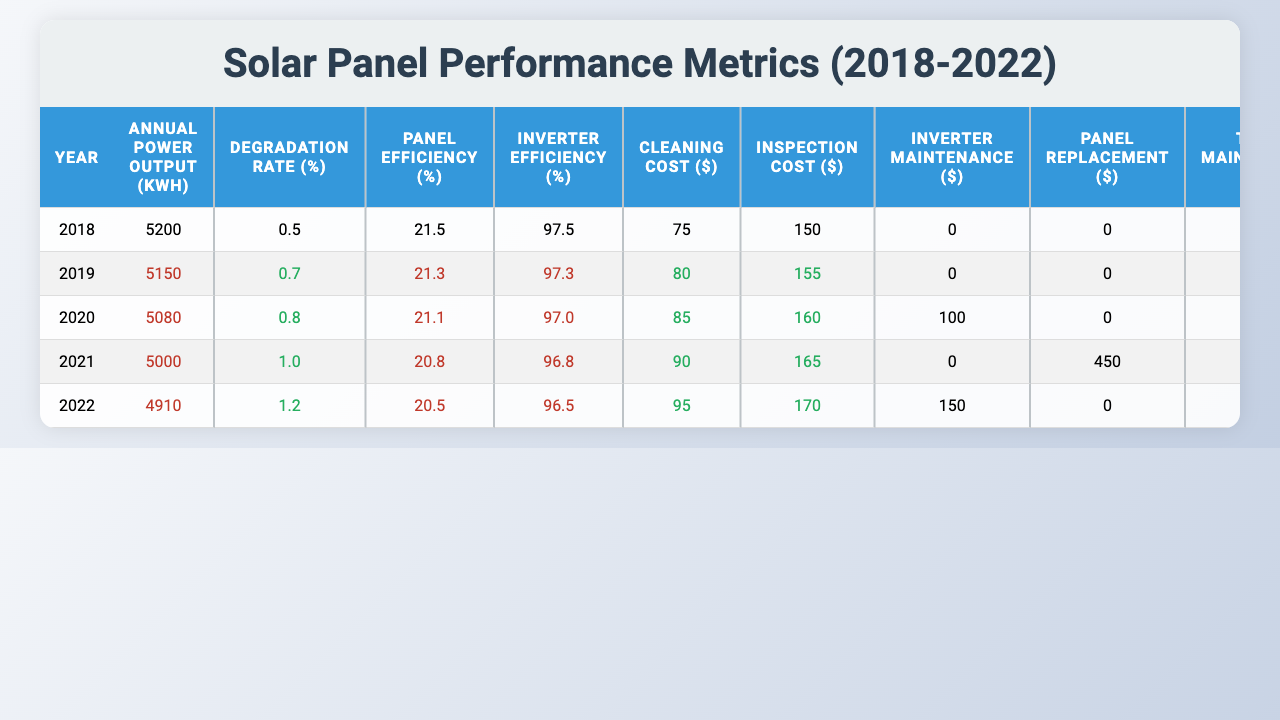What was the annual power output in 2018? The table shows that in the year 2018, the Annual Power Output was 5200 kWh.
Answer: 5200 kWh What was the degradation rate in 2022? In 2022, the degradation rate was recorded as 1.2%.
Answer: 1.2% Which year had the highest total maintenance cost? By comparing the Total Maintenance Cost for each year, the highest value is 705 USD in 2021.
Answer: 2021 What is the difference in energy savings from 2018 to 2022? The energy savings in 2018 were 780 USD, and in 2022, they were 737 USD. The difference is 780 - 737 = 43 USD.
Answer: 43 USD Was there an increase in inverter maintenance costs from 2019 to 2020? In 2019, the Inverter Maintenance Cost was 0 USD, and in 2020 it increased to 100 USD, indicating an increase.
Answer: Yes What was the trend in panel efficiency from 2018 to 2022? The Panel Efficiency decreased each year from 21.5% in 2018 to 20.5% in 2022, showing a downward trend.
Answer: Downward trend On average, how much did cleaning costs increase per year from 2018 to 2022? The cleaning costs went from 75 USD in 2018 to 95 USD in 2022. Across 4 years, the increase is 95 - 75 = 20 USD. The average increase per year is 20 / 4 = 5 USD.
Answer: 5 USD In which year did the most warranty claims occur? According to the table, warranty claims were filed in 2020 and 2021, with the highest number being 1 in both years, no year had more claims.
Answer: 2020 and 2021 Calculate the total CO2 emissions avoided over the 5 years. The CO2 emissions avoided each year are: 3640 + 3605 + 3556 + 3500 + 3437 = 17738 kg.
Answer: 17738 kg Did the solar irradiance increase or decrease from 2018 to 2022? The solar irradiance decreased from 1650 kWh/m² in 2018 to 1630 kWh/m² in 2022, indicating a decrease.
Answer: Decrease What was the total maintenance cost in 2020? The total maintenance cost for 2020 was 345 USD.
Answer: 345 USD 